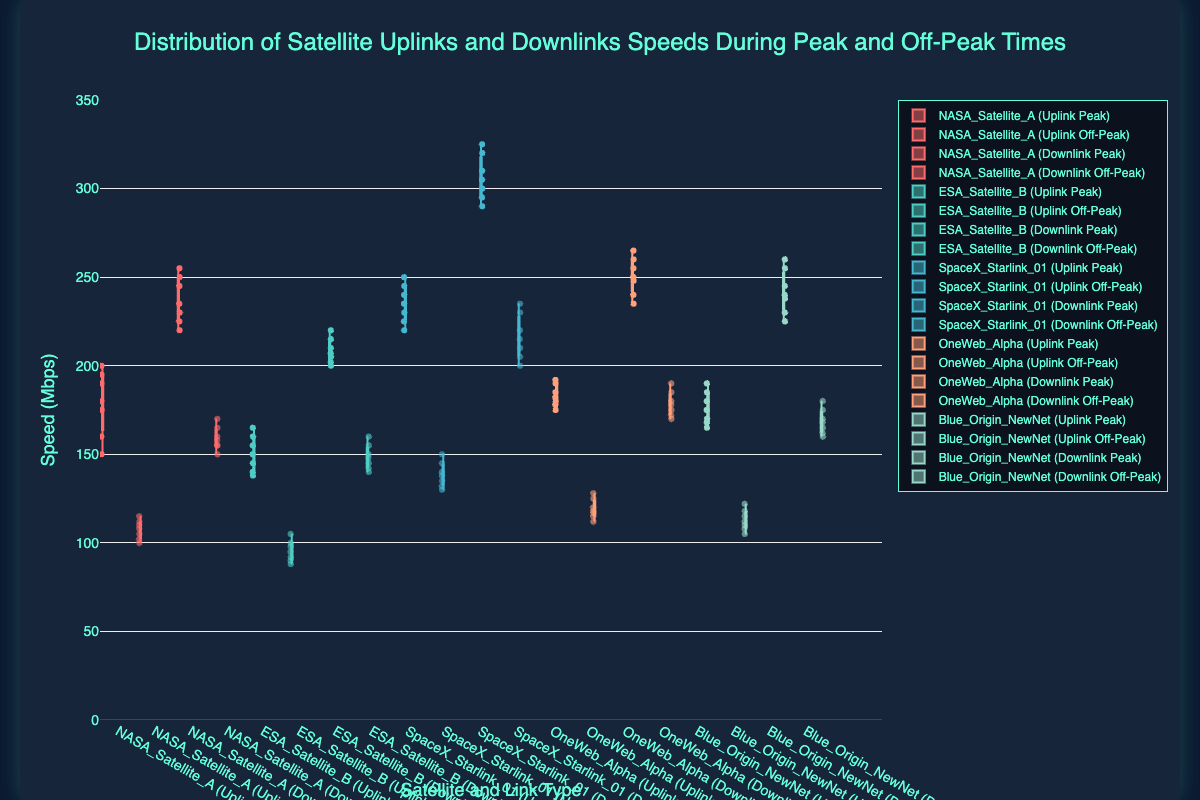What is the title of the box plot? The title of the figure is given at the top. It states the purpose of the figure.
Answer: Distribution of Satellite Uplinks and Downlinks Speeds During Peak and Off-Peak Times Which satellite has the highest uplink speed during peak times? To determine this, compare the upper whiskers (maximum values) of the uplink peak times for all satellites. SpaceX_Starlink_01 has the highest value among all.
Answer: SpaceX_Starlink_01 What is the median downlink speed of NASA_Satellite_A during off-peak times? The median is the line within the box for the NASA_Satellite_A Downlink Off-Peak group. The value is around the middle of the box plot.
Answer: 160 Which satellite has the greatest interquartile range (IQR) for uplink speeds during peak times? The IQR is represented by the height of the box. To find the greatest IQR, measure the height of all boxes in the uplink peak times category.
Answer: SpaceX_Starlink_01 What is the difference between the median uplink speed of SpaceX_Starlink_01 during peak times and off-peak times? Subtract the median of the off-peak times from the median of the peak times for SpaceX_Starlink_01. The median of peak times is 235 and off-peak times is 140.
Answer: 95 Which satellite shows a larger difference in downlink speeds between peak times and off-peak times, SpaceX_Starlink_01 or OneWeb_Alpha? Calculate the difference for both satellites by subtracting off-peak median from peak median, then compare the results. SpaceX_Starlink_01 has a difference of 105 (220-115), and OneWeb_Alpha has a difference of 70 (240-170).
Answer: SpaceX_Starlink_01 Comparing ESA_Satellite_B and Blue_Origin_NewNet, which one has a higher median uplink speed during off-peak times? Look at the median lines within the boxes of the respective satellites' uplink off-peak times to compare.
Answer: Blue_Origin_NewNet For which satellite is the uplink speed during peak times most consistent? Consistency is indicated by the shortest box height, representing a smaller IQR in uplink peak times.
Answer: OneWeb_Alpha Is the median downlink speed during peak times for NASA_Satellite_A higher than for ESA_Satellite_B? Compare the medians within the boxes for downlink peak times of both satellites. The median line for NASA_Satellite_A is higher than ESA_Satellite_B.
Answer: Yes Which satellite has the lowest minimum uplink speed during peak times? The lowest uplink speed will be indicated by the bottom whisker (minimum value) of the uplink peak times.
Answer: ESA_Satellite_B 